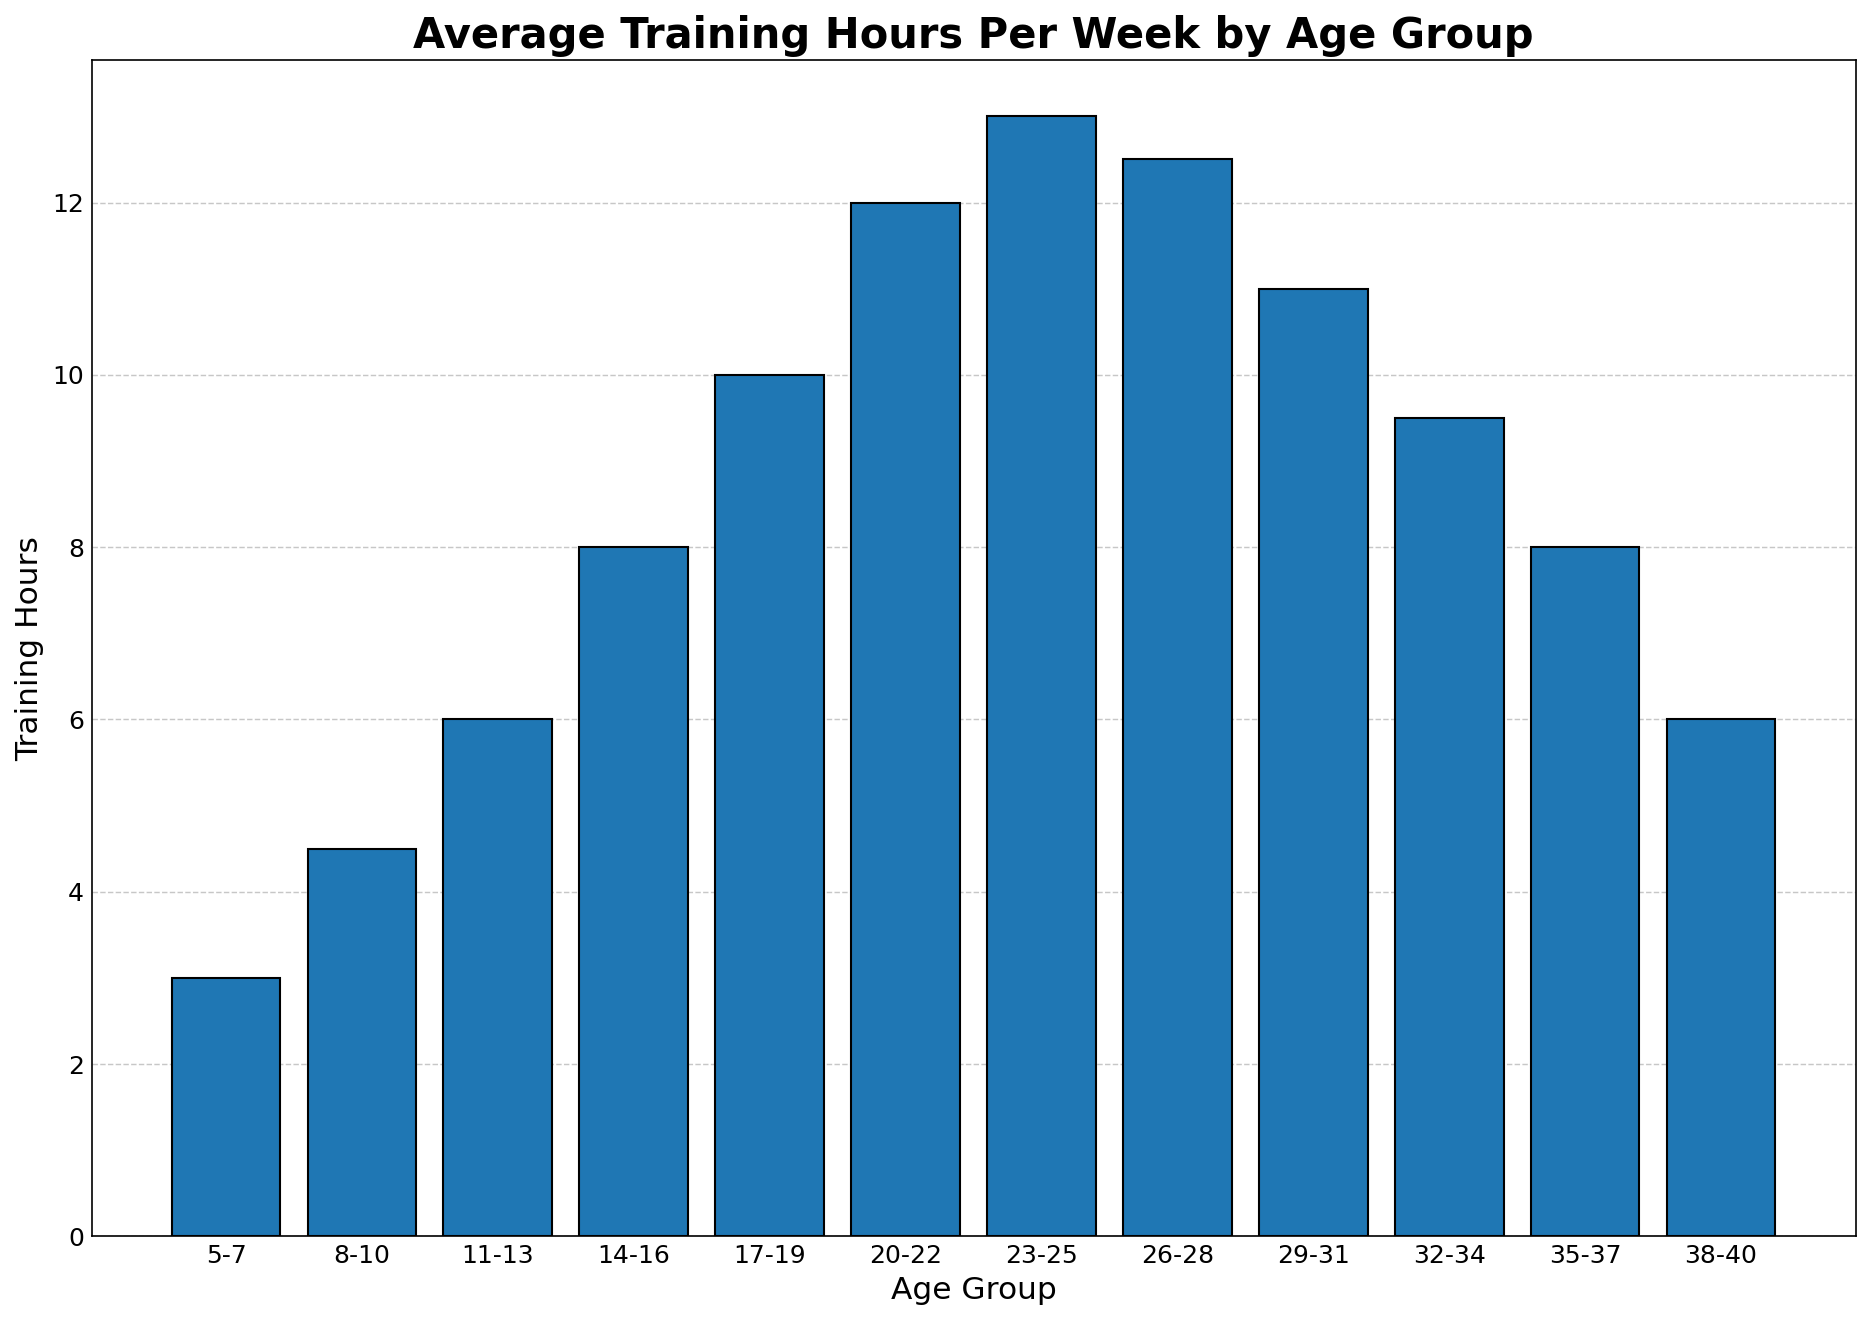Which age group has the highest average training hours per week? By looking at the height of the bars, the age group with the highest bar represents the highest average training hours. The highest bar corresponds to the 23-25 age group.
Answer: 23-25 Which age group has the lowest average training hours per week? By identifying the shortest bar in the graph, we see that the 5-7 age group has the fewest training hours.
Answer: 5-7 What is the difference in average training hours between the 17-19 and 32-34 age groups? According to the figure, the bar for the 17-19 age group reaches 10 training hours, and the bar for the 32-34 age group reaches 9.5 training hours. The difference can be calculated as 10 - 9.5.
Answer: 0.5 How many more training hours does the 23-25 age group have compared to the 14-16 age group? The figure shows 13 training hours for the 23-25 age group and 8 training hours for the 14-16 age group. The difference is 13 - 8.
Answer: 5 Is the average training time for the 26-28 age group higher than for the 29-31 age group? By comparing the bars, the 26-28 age group has an average of 12.5 training hours, while the 29-31 age group has 11 training hours. 12.5 is greater than 11.
Answer: Yes What’s the average training hours per week among the 11-13, 14-16, and 17-19 age groups? The values for these age groups are 6, 8, and 10 respectively. The average is calculated as (6 + 8 + 10) / 3.
Answer: 8 Between which consecutive age groups is there the most significant increase in training hours? By observing the bars, the largest increase occurs between the 14-16 age group (8 hours) and the 17-19 age group (10 hours). The increase is 10 - 8 = 2 hours.
Answer: 14-16 to 17-19 Are the average training hours higher for the 20-22 age group or the 32-34 age group? Checking the bar heights, the 20-22 age group has 12 hours, while the 32-34 age group has 9.5 hours.
Answer: 20-22 What's the total average training hours for the youngest three age groups? The youngest three groups are 5-7, 8-10, and 11-13. Their averages are 3, 4.5, and 6 hours respectively. Summing them gives 3 + 4.5 + 6.
Answer: 13.5 Which age group experiences the first decline in training hours when moving to the next age group? Observing the pattern of the bars, a decline first appears when moving from the 23-25 age group (13 hours) to the 26-28 age group (12.5 hours).
Answer: 23-25 to 26-28 